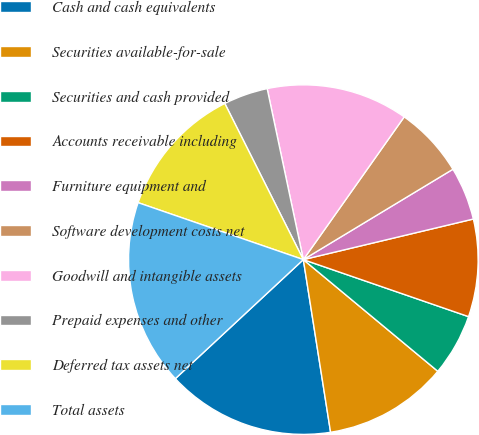Convert chart. <chart><loc_0><loc_0><loc_500><loc_500><pie_chart><fcel>Cash and cash equivalents<fcel>Securities available-for-sale<fcel>Securities and cash provided<fcel>Accounts receivable including<fcel>Furniture equipment and<fcel>Software development costs net<fcel>Goodwill and intangible assets<fcel>Prepaid expenses and other<fcel>Deferred tax assets net<fcel>Total assets<nl><fcel>15.57%<fcel>11.48%<fcel>5.74%<fcel>9.02%<fcel>4.92%<fcel>6.56%<fcel>13.11%<fcel>4.1%<fcel>12.3%<fcel>17.21%<nl></chart> 